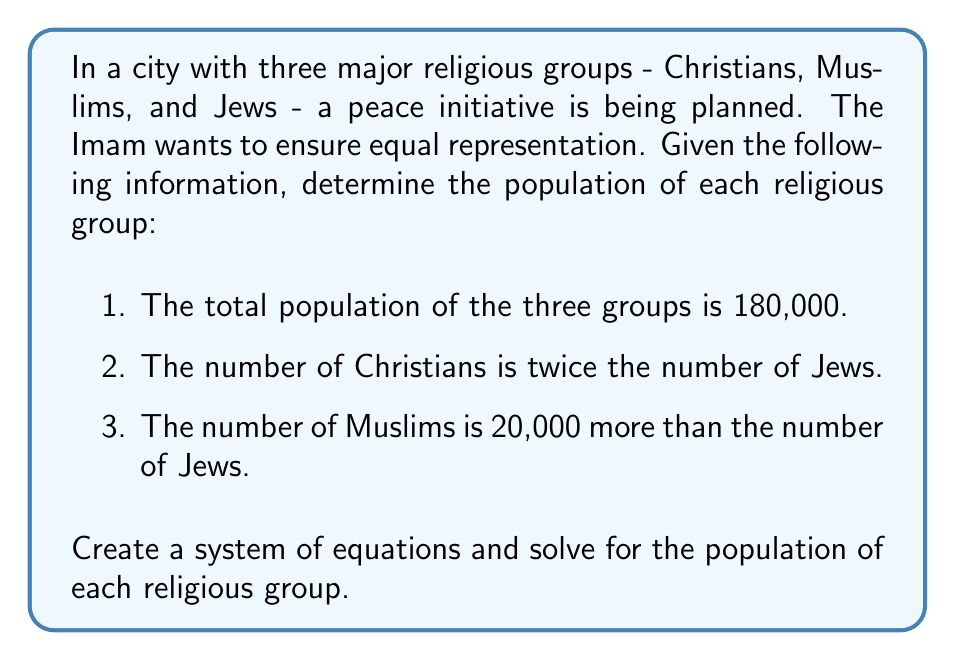Provide a solution to this math problem. Let's approach this step-by-step:

1) Define variables:
   Let $x$ = number of Jews
   Let $y$ = number of Christians
   Let $z$ = number of Muslims

2) Create equations based on the given information:
   Equation 1: $x + y + z = 180,000$ (total population)
   Equation 2: $y = 2x$ (Christians are twice the number of Jews)
   Equation 3: $z = x + 20,000$ (Muslims are 20,000 more than Jews)

3) Substitute Equations 2 and 3 into Equation 1:
   $x + 2x + (x + 20,000) = 180,000$

4) Simplify:
   $4x + 20,000 = 180,000$

5) Solve for $x$:
   $4x = 160,000$
   $x = 40,000$

6) Calculate $y$ and $z$:
   $y = 2x = 2(40,000) = 80,000$
   $z = x + 20,000 = 40,000 + 20,000 = 60,000$

7) Verify the solution:
   $x + y + z = 40,000 + 80,000 + 60,000 = 180,000$

Therefore, the population of Jews is 40,000, Christians is 80,000, and Muslims is 60,000.
Answer: Jews: 40,000; Christians: 80,000; Muslims: 60,000 